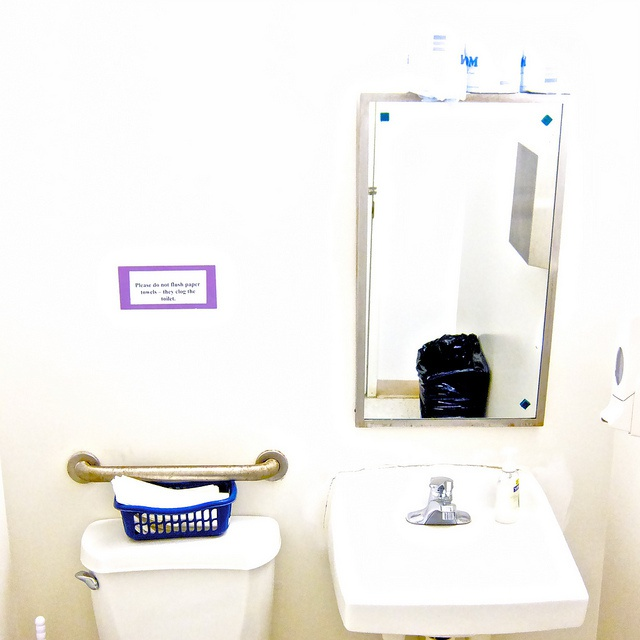Describe the objects in this image and their specific colors. I can see sink in white, darkgray, and tan tones and toilet in white, tan, and darkgray tones in this image. 